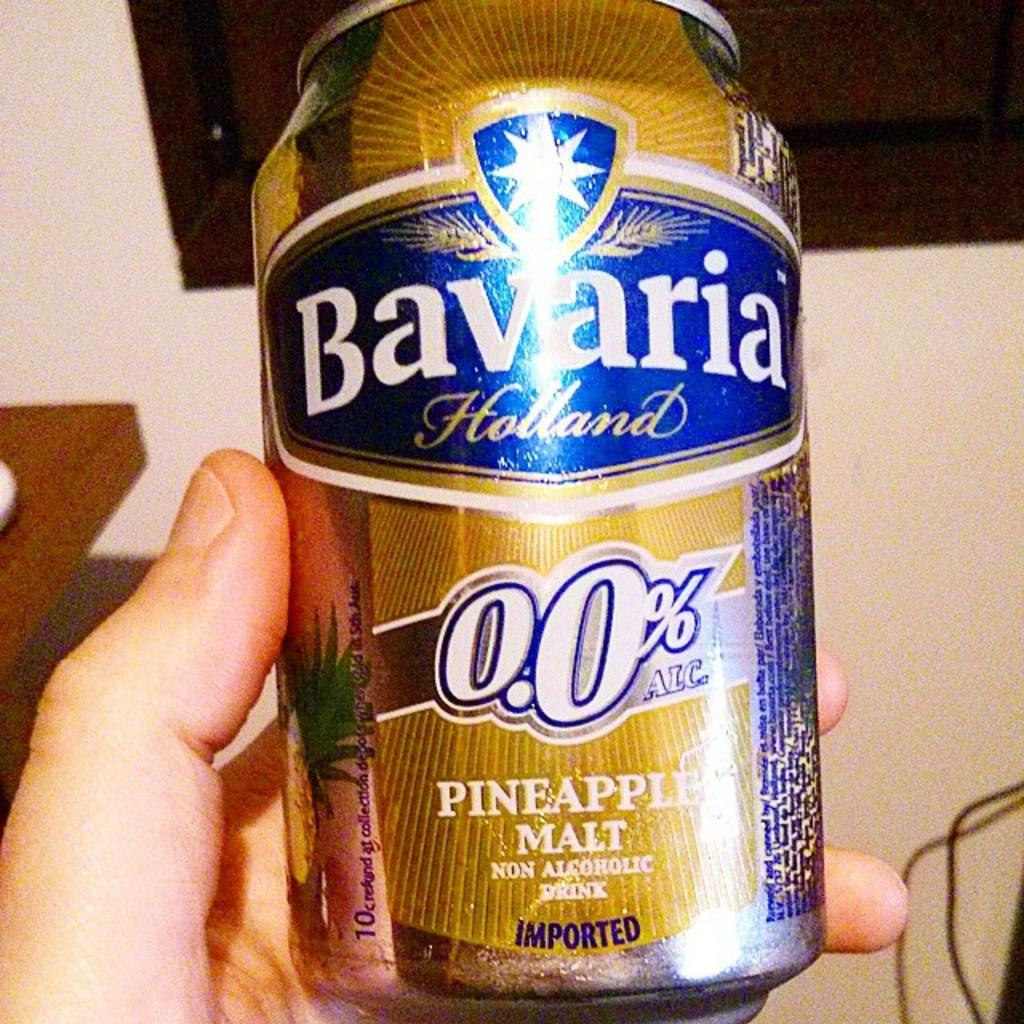What is the main subject of the image? There is a person in the image. What is the person holding in the image? The person is holding a tin. What can be seen in the background of the image? There is a wall, a board, a table, and a wire in the background. What type of market is visible in the background of the image? There is no market present in the image; only a wall, a board, a table, and a wire can be seen in the background. What flavor of dog can be seen in the image? There is no dog present in the image, so it is not possible to determine its flavor. 